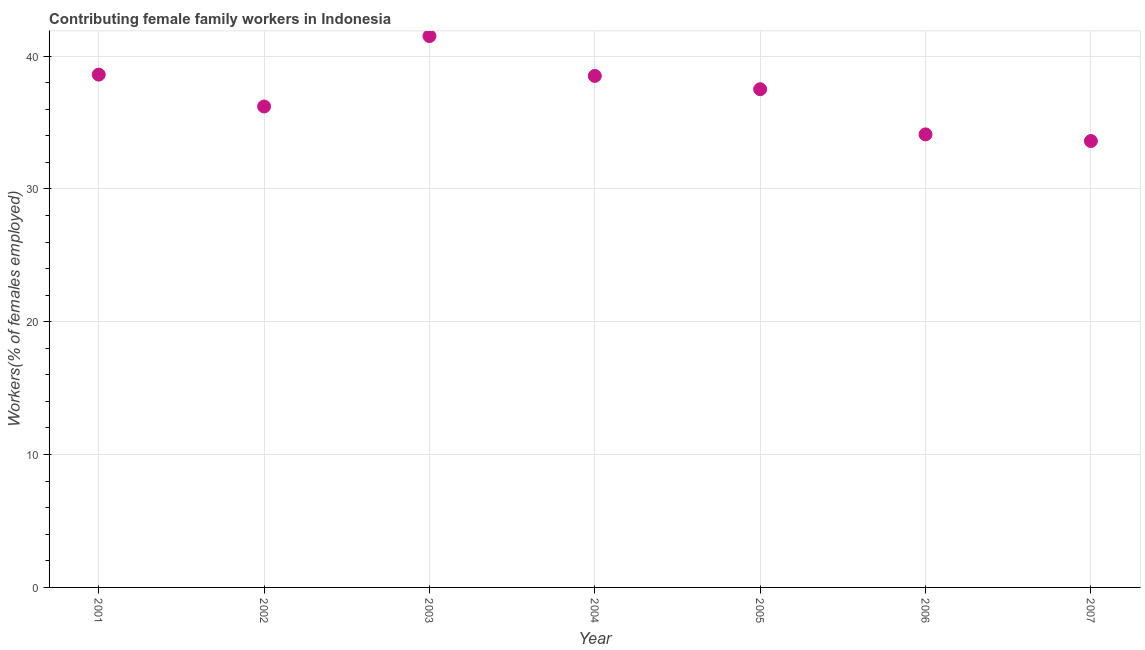What is the contributing female family workers in 2004?
Ensure brevity in your answer.  38.5. Across all years, what is the maximum contributing female family workers?
Ensure brevity in your answer.  41.5. Across all years, what is the minimum contributing female family workers?
Your answer should be compact. 33.6. In which year was the contributing female family workers minimum?
Keep it short and to the point. 2007. What is the sum of the contributing female family workers?
Offer a very short reply. 260. What is the difference between the contributing female family workers in 2001 and 2005?
Provide a short and direct response. 1.1. What is the average contributing female family workers per year?
Provide a succinct answer. 37.14. What is the median contributing female family workers?
Keep it short and to the point. 37.5. In how many years, is the contributing female family workers greater than 34 %?
Offer a terse response. 6. Do a majority of the years between 2003 and 2002 (inclusive) have contributing female family workers greater than 26 %?
Your answer should be very brief. No. What is the ratio of the contributing female family workers in 2001 to that in 2002?
Your answer should be compact. 1.07. What is the difference between the highest and the second highest contributing female family workers?
Offer a terse response. 2.9. What is the difference between the highest and the lowest contributing female family workers?
Offer a very short reply. 7.9. In how many years, is the contributing female family workers greater than the average contributing female family workers taken over all years?
Your answer should be very brief. 4. How many dotlines are there?
Keep it short and to the point. 1. How many years are there in the graph?
Ensure brevity in your answer.  7. Does the graph contain grids?
Your answer should be compact. Yes. What is the title of the graph?
Provide a short and direct response. Contributing female family workers in Indonesia. What is the label or title of the Y-axis?
Provide a succinct answer. Workers(% of females employed). What is the Workers(% of females employed) in 2001?
Offer a very short reply. 38.6. What is the Workers(% of females employed) in 2002?
Provide a succinct answer. 36.2. What is the Workers(% of females employed) in 2003?
Provide a succinct answer. 41.5. What is the Workers(% of females employed) in 2004?
Your answer should be very brief. 38.5. What is the Workers(% of females employed) in 2005?
Offer a very short reply. 37.5. What is the Workers(% of females employed) in 2006?
Offer a very short reply. 34.1. What is the Workers(% of females employed) in 2007?
Offer a very short reply. 33.6. What is the difference between the Workers(% of females employed) in 2001 and 2002?
Your answer should be compact. 2.4. What is the difference between the Workers(% of females employed) in 2001 and 2004?
Give a very brief answer. 0.1. What is the difference between the Workers(% of females employed) in 2001 and 2005?
Your answer should be very brief. 1.1. What is the difference between the Workers(% of females employed) in 2002 and 2006?
Your answer should be compact. 2.1. What is the difference between the Workers(% of females employed) in 2003 and 2006?
Offer a very short reply. 7.4. What is the difference between the Workers(% of females employed) in 2004 and 2005?
Give a very brief answer. 1. What is the difference between the Workers(% of females employed) in 2004 and 2007?
Ensure brevity in your answer.  4.9. What is the ratio of the Workers(% of females employed) in 2001 to that in 2002?
Provide a succinct answer. 1.07. What is the ratio of the Workers(% of females employed) in 2001 to that in 2003?
Your answer should be compact. 0.93. What is the ratio of the Workers(% of females employed) in 2001 to that in 2004?
Provide a short and direct response. 1. What is the ratio of the Workers(% of females employed) in 2001 to that in 2006?
Your response must be concise. 1.13. What is the ratio of the Workers(% of females employed) in 2001 to that in 2007?
Your answer should be compact. 1.15. What is the ratio of the Workers(% of females employed) in 2002 to that in 2003?
Offer a very short reply. 0.87. What is the ratio of the Workers(% of females employed) in 2002 to that in 2006?
Provide a short and direct response. 1.06. What is the ratio of the Workers(% of females employed) in 2002 to that in 2007?
Make the answer very short. 1.08. What is the ratio of the Workers(% of females employed) in 2003 to that in 2004?
Make the answer very short. 1.08. What is the ratio of the Workers(% of females employed) in 2003 to that in 2005?
Provide a short and direct response. 1.11. What is the ratio of the Workers(% of females employed) in 2003 to that in 2006?
Ensure brevity in your answer.  1.22. What is the ratio of the Workers(% of females employed) in 2003 to that in 2007?
Your answer should be very brief. 1.24. What is the ratio of the Workers(% of females employed) in 2004 to that in 2005?
Keep it short and to the point. 1.03. What is the ratio of the Workers(% of females employed) in 2004 to that in 2006?
Give a very brief answer. 1.13. What is the ratio of the Workers(% of females employed) in 2004 to that in 2007?
Give a very brief answer. 1.15. What is the ratio of the Workers(% of females employed) in 2005 to that in 2007?
Provide a short and direct response. 1.12. 